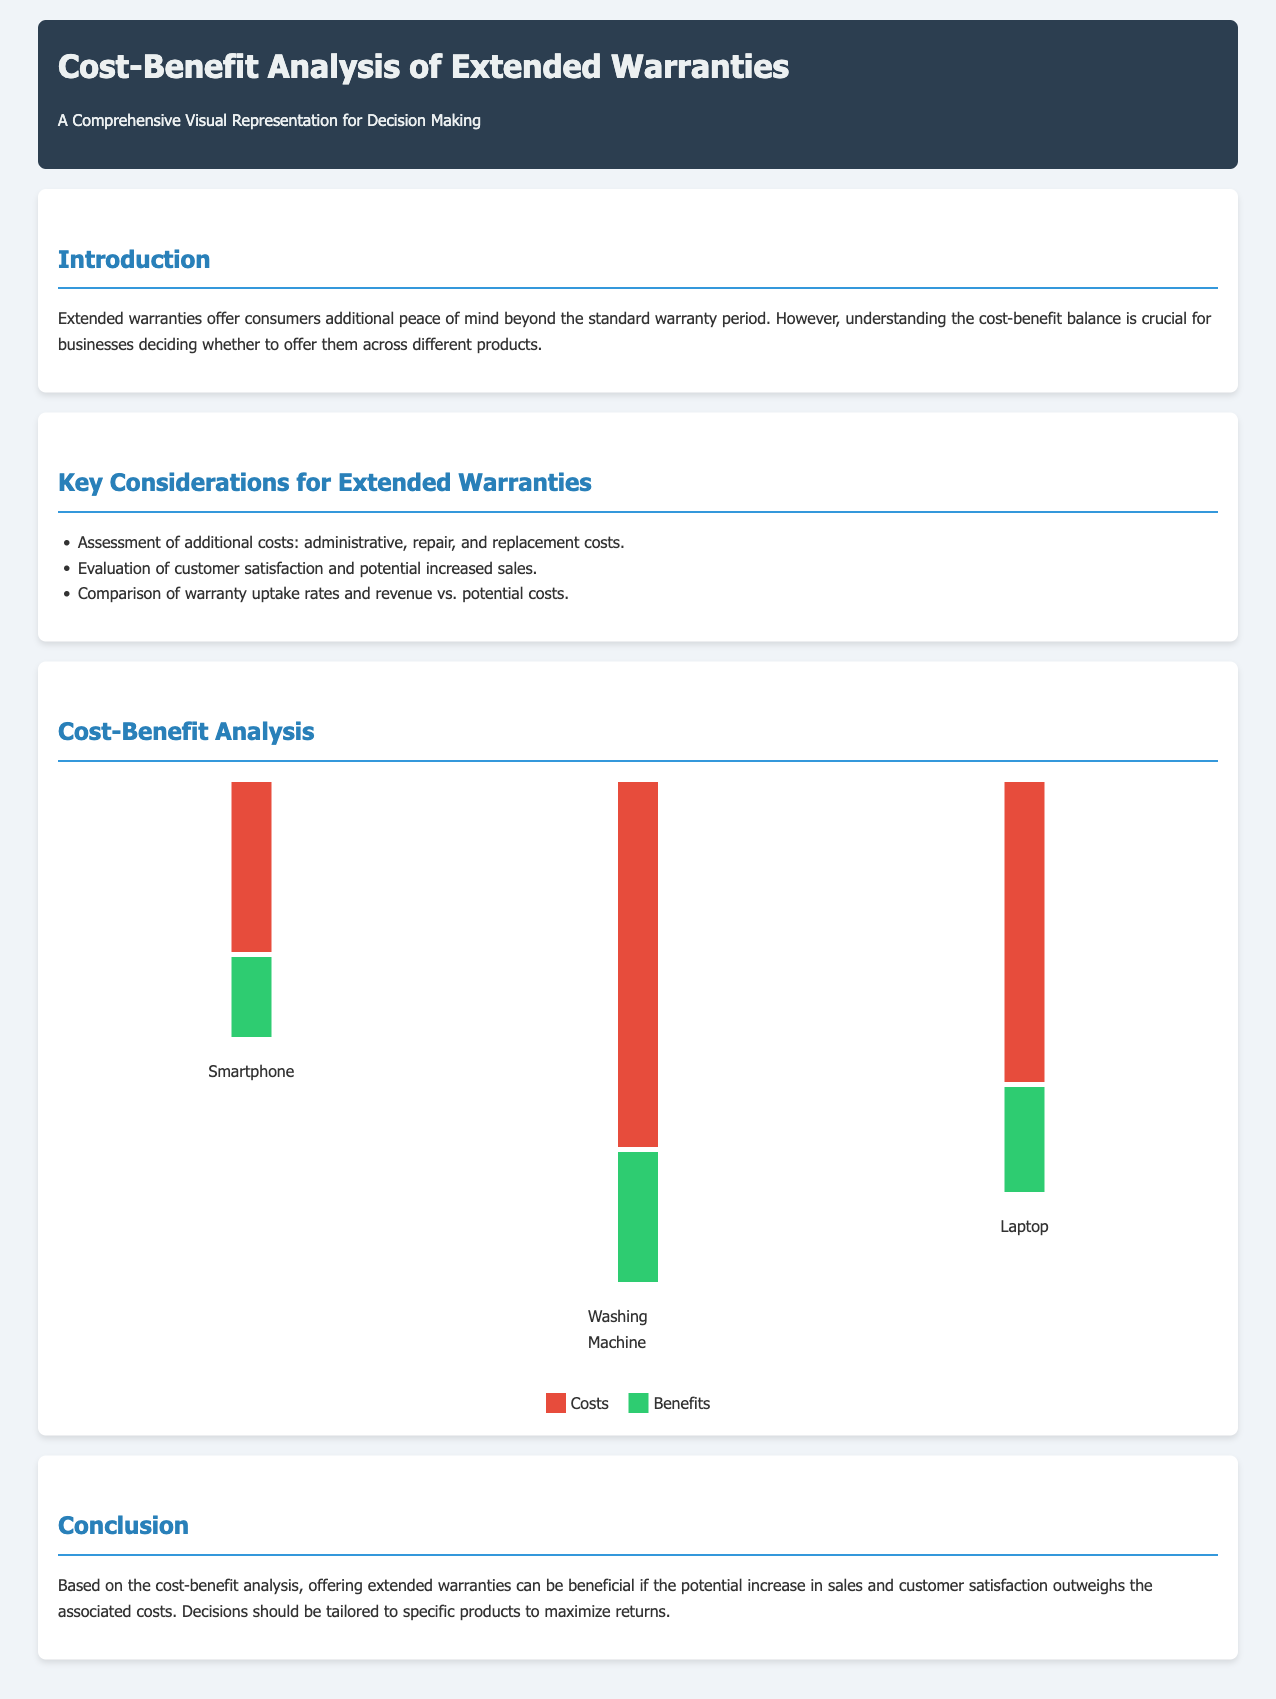What is the main purpose of the document? The document aims to visually represent the cost-benefit analysis of extended warranties for decision-making.
Answer: Visual representation of cost-benefit analysis Which product has the highest costs associated with extended warranties? The costs bar for the Washing Machine is the tallest, indicating it has the highest costs.
Answer: Washing Machine What is the height of the benefits bar for Smartphones? The benefits bar for Smartphones is shorter than the others, with a height of 80 pixels.
Answer: 80 What are the two key considerations mentioned for extended warranties? The considerations include assessment of costs and evaluation of customer satisfaction.
Answer: Assessment of costs and evaluation of customer satisfaction Based on the chart, which product has the lowest benefits compared to its costs? Comparing the heights of the benefits and costs bars shows that the Laptop has lower benefits relative to its costs.
Answer: Laptop What color represents costs in the chart? The costs bar is colored red, specifically a shade (#e74c3c).
Answer: Red What conclusion is drawn about offering extended warranties? The conclusion indicates that if sales increase surpass costs, warranties can be beneficial.
Answer: Beneficial if sales increase surpass costs How many products are analyzed in the document? Three products are displayed in the cost-benefit analysis within the document.
Answer: Three products 